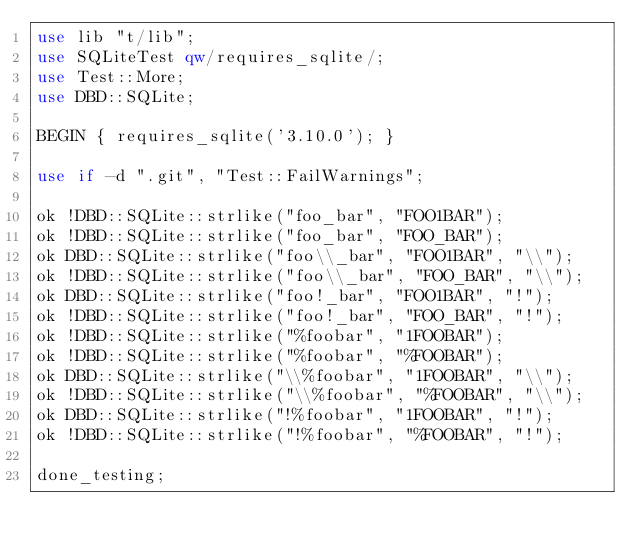Convert code to text. <code><loc_0><loc_0><loc_500><loc_500><_Perl_>use lib "t/lib";
use SQLiteTest qw/requires_sqlite/;
use Test::More;
use DBD::SQLite;

BEGIN { requires_sqlite('3.10.0'); }

use if -d ".git", "Test::FailWarnings";

ok !DBD::SQLite::strlike("foo_bar", "FOO1BAR");
ok !DBD::SQLite::strlike("foo_bar", "FOO_BAR");
ok DBD::SQLite::strlike("foo\\_bar", "FOO1BAR", "\\");
ok !DBD::SQLite::strlike("foo\\_bar", "FOO_BAR", "\\");
ok DBD::SQLite::strlike("foo!_bar", "FOO1BAR", "!");
ok !DBD::SQLite::strlike("foo!_bar", "FOO_BAR", "!");
ok !DBD::SQLite::strlike("%foobar", "1FOOBAR");
ok !DBD::SQLite::strlike("%foobar", "%FOOBAR");
ok DBD::SQLite::strlike("\\%foobar", "1FOOBAR", "\\");
ok !DBD::SQLite::strlike("\\%foobar", "%FOOBAR", "\\");
ok DBD::SQLite::strlike("!%foobar", "1FOOBAR", "!");
ok !DBD::SQLite::strlike("!%foobar", "%FOOBAR", "!");

done_testing;
</code> 